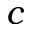<formula> <loc_0><loc_0><loc_500><loc_500>c</formula> 